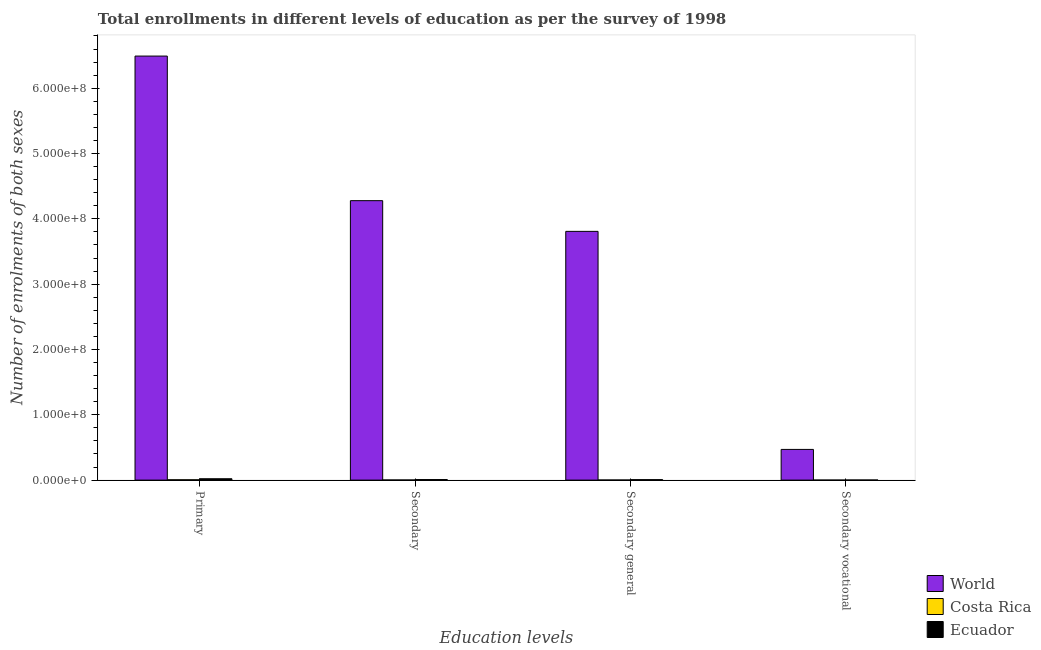How many different coloured bars are there?
Your answer should be compact. 3. How many groups of bars are there?
Offer a terse response. 4. How many bars are there on the 4th tick from the left?
Make the answer very short. 3. How many bars are there on the 2nd tick from the right?
Offer a terse response. 3. What is the label of the 3rd group of bars from the left?
Your answer should be compact. Secondary general. What is the number of enrolments in secondary general education in Costa Rica?
Provide a short and direct response. 1.58e+05. Across all countries, what is the maximum number of enrolments in secondary education?
Make the answer very short. 4.28e+08. Across all countries, what is the minimum number of enrolments in secondary general education?
Keep it short and to the point. 1.58e+05. In which country was the number of enrolments in primary education minimum?
Your answer should be very brief. Costa Rica. What is the total number of enrolments in secondary general education in the graph?
Your response must be concise. 3.82e+08. What is the difference between the number of enrolments in secondary general education in Costa Rica and that in World?
Your answer should be very brief. -3.81e+08. What is the difference between the number of enrolments in primary education in Ecuador and the number of enrolments in secondary general education in Costa Rica?
Offer a terse response. 1.94e+06. What is the average number of enrolments in secondary education per country?
Provide a succinct answer. 1.43e+08. What is the difference between the number of enrolments in secondary education and number of enrolments in secondary vocational education in Costa Rica?
Make the answer very short. 1.58e+05. In how many countries, is the number of enrolments in secondary vocational education greater than 280000000 ?
Your response must be concise. 0. What is the ratio of the number of enrolments in secondary education in Ecuador to that in Costa Rica?
Your response must be concise. 4.28. Is the number of enrolments in primary education in Costa Rica less than that in Ecuador?
Ensure brevity in your answer.  Yes. What is the difference between the highest and the second highest number of enrolments in secondary vocational education?
Offer a very short reply. 4.68e+07. What is the difference between the highest and the lowest number of enrolments in secondary general education?
Ensure brevity in your answer.  3.81e+08. In how many countries, is the number of enrolments in secondary general education greater than the average number of enrolments in secondary general education taken over all countries?
Keep it short and to the point. 1. What does the 2nd bar from the left in Secondary general represents?
Provide a short and direct response. Costa Rica. What does the 1st bar from the right in Secondary vocational represents?
Keep it short and to the point. Ecuador. Are all the bars in the graph horizontal?
Provide a short and direct response. No. Does the graph contain any zero values?
Your response must be concise. No. Does the graph contain grids?
Keep it short and to the point. No. How are the legend labels stacked?
Keep it short and to the point. Vertical. What is the title of the graph?
Make the answer very short. Total enrollments in different levels of education as per the survey of 1998. What is the label or title of the X-axis?
Offer a very short reply. Education levels. What is the label or title of the Y-axis?
Offer a terse response. Number of enrolments of both sexes. What is the Number of enrolments of both sexes of World in Primary?
Offer a very short reply. 6.49e+08. What is the Number of enrolments of both sexes of Costa Rica in Primary?
Keep it short and to the point. 5.30e+05. What is the Number of enrolments of both sexes in Ecuador in Primary?
Your answer should be very brief. 2.10e+06. What is the Number of enrolments of both sexes in World in Secondary?
Your response must be concise. 4.28e+08. What is the Number of enrolments of both sexes in Costa Rica in Secondary?
Offer a very short reply. 2.02e+05. What is the Number of enrolments of both sexes of Ecuador in Secondary?
Give a very brief answer. 8.67e+05. What is the Number of enrolments of both sexes in World in Secondary general?
Offer a very short reply. 3.81e+08. What is the Number of enrolments of both sexes in Costa Rica in Secondary general?
Your answer should be very brief. 1.58e+05. What is the Number of enrolments of both sexes of Ecuador in Secondary general?
Your response must be concise. 7.01e+05. What is the Number of enrolments of both sexes in World in Secondary vocational?
Ensure brevity in your answer.  4.70e+07. What is the Number of enrolments of both sexes of Costa Rica in Secondary vocational?
Provide a succinct answer. 4.43e+04. What is the Number of enrolments of both sexes of Ecuador in Secondary vocational?
Provide a short and direct response. 1.66e+05. Across all Education levels, what is the maximum Number of enrolments of both sexes of World?
Ensure brevity in your answer.  6.49e+08. Across all Education levels, what is the maximum Number of enrolments of both sexes in Costa Rica?
Your answer should be compact. 5.30e+05. Across all Education levels, what is the maximum Number of enrolments of both sexes in Ecuador?
Offer a very short reply. 2.10e+06. Across all Education levels, what is the minimum Number of enrolments of both sexes of World?
Ensure brevity in your answer.  4.70e+07. Across all Education levels, what is the minimum Number of enrolments of both sexes in Costa Rica?
Ensure brevity in your answer.  4.43e+04. Across all Education levels, what is the minimum Number of enrolments of both sexes in Ecuador?
Your response must be concise. 1.66e+05. What is the total Number of enrolments of both sexes in World in the graph?
Provide a succinct answer. 1.50e+09. What is the total Number of enrolments of both sexes in Costa Rica in the graph?
Make the answer very short. 9.34e+05. What is the total Number of enrolments of both sexes in Ecuador in the graph?
Your answer should be compact. 3.83e+06. What is the difference between the Number of enrolments of both sexes in World in Primary and that in Secondary?
Your response must be concise. 2.21e+08. What is the difference between the Number of enrolments of both sexes of Costa Rica in Primary and that in Secondary?
Your answer should be very brief. 3.27e+05. What is the difference between the Number of enrolments of both sexes of Ecuador in Primary and that in Secondary?
Ensure brevity in your answer.  1.23e+06. What is the difference between the Number of enrolments of both sexes of World in Primary and that in Secondary general?
Keep it short and to the point. 2.68e+08. What is the difference between the Number of enrolments of both sexes in Costa Rica in Primary and that in Secondary general?
Give a very brief answer. 3.72e+05. What is the difference between the Number of enrolments of both sexes of Ecuador in Primary and that in Secondary general?
Provide a short and direct response. 1.40e+06. What is the difference between the Number of enrolments of both sexes of World in Primary and that in Secondary vocational?
Offer a terse response. 6.02e+08. What is the difference between the Number of enrolments of both sexes of Costa Rica in Primary and that in Secondary vocational?
Offer a very short reply. 4.85e+05. What is the difference between the Number of enrolments of both sexes of Ecuador in Primary and that in Secondary vocational?
Your answer should be compact. 1.93e+06. What is the difference between the Number of enrolments of both sexes of World in Secondary and that in Secondary general?
Offer a very short reply. 4.70e+07. What is the difference between the Number of enrolments of both sexes of Costa Rica in Secondary and that in Secondary general?
Your response must be concise. 4.43e+04. What is the difference between the Number of enrolments of both sexes in Ecuador in Secondary and that in Secondary general?
Give a very brief answer. 1.66e+05. What is the difference between the Number of enrolments of both sexes in World in Secondary and that in Secondary vocational?
Offer a terse response. 3.81e+08. What is the difference between the Number of enrolments of both sexes of Costa Rica in Secondary and that in Secondary vocational?
Make the answer very short. 1.58e+05. What is the difference between the Number of enrolments of both sexes of Ecuador in Secondary and that in Secondary vocational?
Give a very brief answer. 7.01e+05. What is the difference between the Number of enrolments of both sexes in World in Secondary general and that in Secondary vocational?
Make the answer very short. 3.34e+08. What is the difference between the Number of enrolments of both sexes in Costa Rica in Secondary general and that in Secondary vocational?
Your answer should be very brief. 1.14e+05. What is the difference between the Number of enrolments of both sexes of Ecuador in Secondary general and that in Secondary vocational?
Your response must be concise. 5.35e+05. What is the difference between the Number of enrolments of both sexes of World in Primary and the Number of enrolments of both sexes of Costa Rica in Secondary?
Offer a very short reply. 6.49e+08. What is the difference between the Number of enrolments of both sexes in World in Primary and the Number of enrolments of both sexes in Ecuador in Secondary?
Your response must be concise. 6.48e+08. What is the difference between the Number of enrolments of both sexes in Costa Rica in Primary and the Number of enrolments of both sexes in Ecuador in Secondary?
Give a very brief answer. -3.37e+05. What is the difference between the Number of enrolments of both sexes in World in Primary and the Number of enrolments of both sexes in Costa Rica in Secondary general?
Your answer should be compact. 6.49e+08. What is the difference between the Number of enrolments of both sexes in World in Primary and the Number of enrolments of both sexes in Ecuador in Secondary general?
Offer a very short reply. 6.48e+08. What is the difference between the Number of enrolments of both sexes of Costa Rica in Primary and the Number of enrolments of both sexes of Ecuador in Secondary general?
Offer a very short reply. -1.71e+05. What is the difference between the Number of enrolments of both sexes in World in Primary and the Number of enrolments of both sexes in Costa Rica in Secondary vocational?
Ensure brevity in your answer.  6.49e+08. What is the difference between the Number of enrolments of both sexes of World in Primary and the Number of enrolments of both sexes of Ecuador in Secondary vocational?
Your answer should be very brief. 6.49e+08. What is the difference between the Number of enrolments of both sexes of Costa Rica in Primary and the Number of enrolments of both sexes of Ecuador in Secondary vocational?
Offer a terse response. 3.64e+05. What is the difference between the Number of enrolments of both sexes of World in Secondary and the Number of enrolments of both sexes of Costa Rica in Secondary general?
Your answer should be very brief. 4.28e+08. What is the difference between the Number of enrolments of both sexes of World in Secondary and the Number of enrolments of both sexes of Ecuador in Secondary general?
Keep it short and to the point. 4.27e+08. What is the difference between the Number of enrolments of both sexes in Costa Rica in Secondary and the Number of enrolments of both sexes in Ecuador in Secondary general?
Ensure brevity in your answer.  -4.98e+05. What is the difference between the Number of enrolments of both sexes in World in Secondary and the Number of enrolments of both sexes in Costa Rica in Secondary vocational?
Make the answer very short. 4.28e+08. What is the difference between the Number of enrolments of both sexes of World in Secondary and the Number of enrolments of both sexes of Ecuador in Secondary vocational?
Your answer should be very brief. 4.28e+08. What is the difference between the Number of enrolments of both sexes in Costa Rica in Secondary and the Number of enrolments of both sexes in Ecuador in Secondary vocational?
Make the answer very short. 3.66e+04. What is the difference between the Number of enrolments of both sexes in World in Secondary general and the Number of enrolments of both sexes in Costa Rica in Secondary vocational?
Give a very brief answer. 3.81e+08. What is the difference between the Number of enrolments of both sexes in World in Secondary general and the Number of enrolments of both sexes in Ecuador in Secondary vocational?
Give a very brief answer. 3.81e+08. What is the difference between the Number of enrolments of both sexes of Costa Rica in Secondary general and the Number of enrolments of both sexes of Ecuador in Secondary vocational?
Keep it short and to the point. -7748. What is the average Number of enrolments of both sexes of World per Education levels?
Your response must be concise. 3.76e+08. What is the average Number of enrolments of both sexes in Costa Rica per Education levels?
Your answer should be compact. 2.34e+05. What is the average Number of enrolments of both sexes in Ecuador per Education levels?
Give a very brief answer. 9.58e+05. What is the difference between the Number of enrolments of both sexes of World and Number of enrolments of both sexes of Costa Rica in Primary?
Your response must be concise. 6.49e+08. What is the difference between the Number of enrolments of both sexes of World and Number of enrolments of both sexes of Ecuador in Primary?
Ensure brevity in your answer.  6.47e+08. What is the difference between the Number of enrolments of both sexes of Costa Rica and Number of enrolments of both sexes of Ecuador in Primary?
Your response must be concise. -1.57e+06. What is the difference between the Number of enrolments of both sexes of World and Number of enrolments of both sexes of Costa Rica in Secondary?
Your response must be concise. 4.28e+08. What is the difference between the Number of enrolments of both sexes of World and Number of enrolments of both sexes of Ecuador in Secondary?
Keep it short and to the point. 4.27e+08. What is the difference between the Number of enrolments of both sexes in Costa Rica and Number of enrolments of both sexes in Ecuador in Secondary?
Offer a terse response. -6.64e+05. What is the difference between the Number of enrolments of both sexes in World and Number of enrolments of both sexes in Costa Rica in Secondary general?
Make the answer very short. 3.81e+08. What is the difference between the Number of enrolments of both sexes of World and Number of enrolments of both sexes of Ecuador in Secondary general?
Make the answer very short. 3.80e+08. What is the difference between the Number of enrolments of both sexes of Costa Rica and Number of enrolments of both sexes of Ecuador in Secondary general?
Keep it short and to the point. -5.43e+05. What is the difference between the Number of enrolments of both sexes of World and Number of enrolments of both sexes of Costa Rica in Secondary vocational?
Provide a succinct answer. 4.70e+07. What is the difference between the Number of enrolments of both sexes in World and Number of enrolments of both sexes in Ecuador in Secondary vocational?
Your answer should be compact. 4.68e+07. What is the difference between the Number of enrolments of both sexes of Costa Rica and Number of enrolments of both sexes of Ecuador in Secondary vocational?
Give a very brief answer. -1.22e+05. What is the ratio of the Number of enrolments of both sexes of World in Primary to that in Secondary?
Offer a very short reply. 1.52. What is the ratio of the Number of enrolments of both sexes in Costa Rica in Primary to that in Secondary?
Your response must be concise. 2.62. What is the ratio of the Number of enrolments of both sexes of Ecuador in Primary to that in Secondary?
Ensure brevity in your answer.  2.42. What is the ratio of the Number of enrolments of both sexes in World in Primary to that in Secondary general?
Your answer should be compact. 1.7. What is the ratio of the Number of enrolments of both sexes in Costa Rica in Primary to that in Secondary general?
Your answer should be very brief. 3.35. What is the ratio of the Number of enrolments of both sexes in Ecuador in Primary to that in Secondary general?
Offer a terse response. 2.99. What is the ratio of the Number of enrolments of both sexes of World in Primary to that in Secondary vocational?
Offer a terse response. 13.81. What is the ratio of the Number of enrolments of both sexes in Costa Rica in Primary to that in Secondary vocational?
Your answer should be compact. 11.95. What is the ratio of the Number of enrolments of both sexes in Ecuador in Primary to that in Secondary vocational?
Provide a succinct answer. 12.65. What is the ratio of the Number of enrolments of both sexes of World in Secondary to that in Secondary general?
Ensure brevity in your answer.  1.12. What is the ratio of the Number of enrolments of both sexes in Costa Rica in Secondary to that in Secondary general?
Your answer should be very brief. 1.28. What is the ratio of the Number of enrolments of both sexes in Ecuador in Secondary to that in Secondary general?
Offer a terse response. 1.24. What is the ratio of the Number of enrolments of both sexes of World in Secondary to that in Secondary vocational?
Make the answer very short. 9.1. What is the ratio of the Number of enrolments of both sexes of Costa Rica in Secondary to that in Secondary vocational?
Ensure brevity in your answer.  4.57. What is the ratio of the Number of enrolments of both sexes of Ecuador in Secondary to that in Secondary vocational?
Give a very brief answer. 5.23. What is the ratio of the Number of enrolments of both sexes of World in Secondary general to that in Secondary vocational?
Offer a very short reply. 8.1. What is the ratio of the Number of enrolments of both sexes in Costa Rica in Secondary general to that in Secondary vocational?
Make the answer very short. 3.57. What is the ratio of the Number of enrolments of both sexes in Ecuador in Secondary general to that in Secondary vocational?
Your response must be concise. 4.23. What is the difference between the highest and the second highest Number of enrolments of both sexes in World?
Give a very brief answer. 2.21e+08. What is the difference between the highest and the second highest Number of enrolments of both sexes of Costa Rica?
Give a very brief answer. 3.27e+05. What is the difference between the highest and the second highest Number of enrolments of both sexes of Ecuador?
Offer a terse response. 1.23e+06. What is the difference between the highest and the lowest Number of enrolments of both sexes in World?
Offer a terse response. 6.02e+08. What is the difference between the highest and the lowest Number of enrolments of both sexes in Costa Rica?
Make the answer very short. 4.85e+05. What is the difference between the highest and the lowest Number of enrolments of both sexes in Ecuador?
Keep it short and to the point. 1.93e+06. 